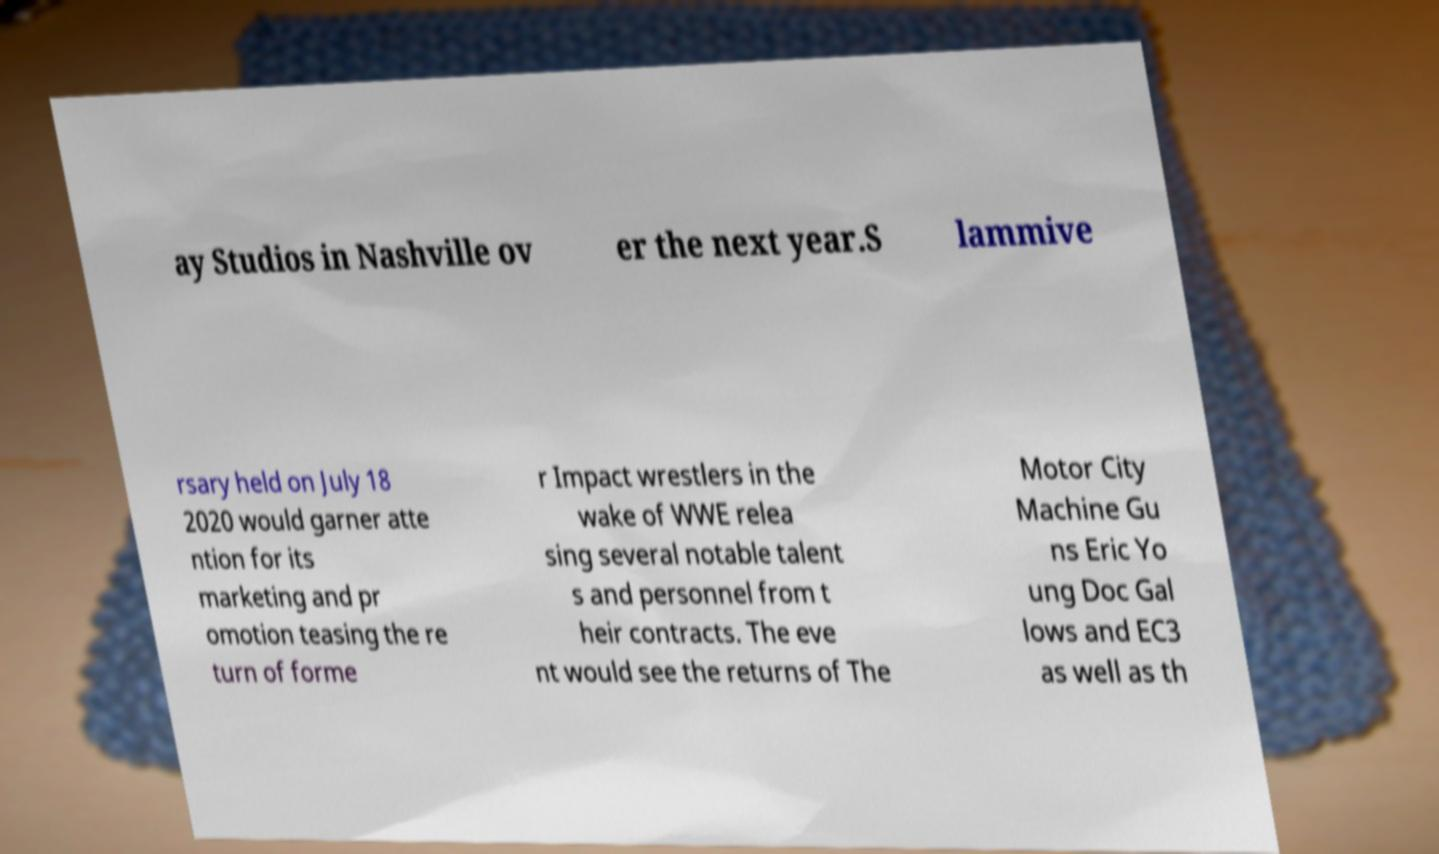Can you read and provide the text displayed in the image?This photo seems to have some interesting text. Can you extract and type it out for me? ay Studios in Nashville ov er the next year.S lammive rsary held on July 18 2020 would garner atte ntion for its marketing and pr omotion teasing the re turn of forme r Impact wrestlers in the wake of WWE relea sing several notable talent s and personnel from t heir contracts. The eve nt would see the returns of The Motor City Machine Gu ns Eric Yo ung Doc Gal lows and EC3 as well as th 